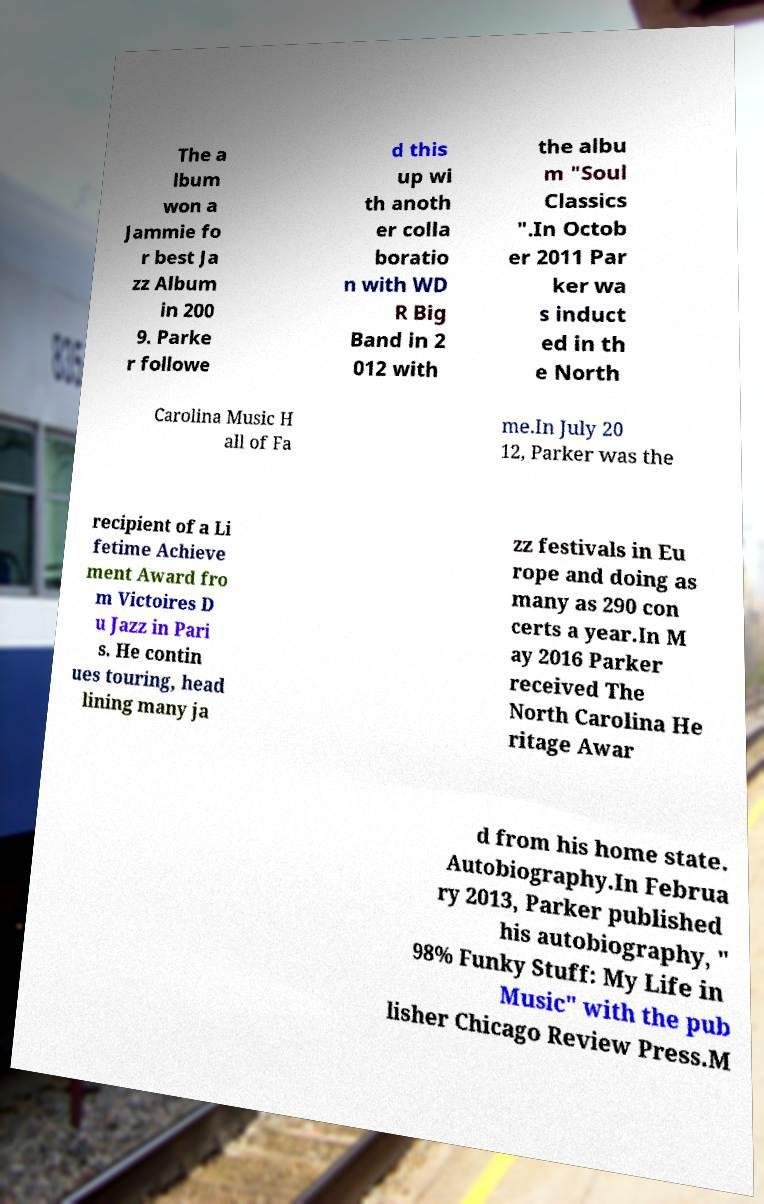Please identify and transcribe the text found in this image. The a lbum won a Jammie fo r best Ja zz Album in 200 9. Parke r followe d this up wi th anoth er colla boratio n with WD R Big Band in 2 012 with the albu m "Soul Classics ".In Octob er 2011 Par ker wa s induct ed in th e North Carolina Music H all of Fa me.In July 20 12, Parker was the recipient of a Li fetime Achieve ment Award fro m Victoires D u Jazz in Pari s. He contin ues touring, head lining many ja zz festivals in Eu rope and doing as many as 290 con certs a year.In M ay 2016 Parker received The North Carolina He ritage Awar d from his home state. Autobiography.In Februa ry 2013, Parker published his autobiography, " 98% Funky Stuff: My Life in Music" with the pub lisher Chicago Review Press.M 